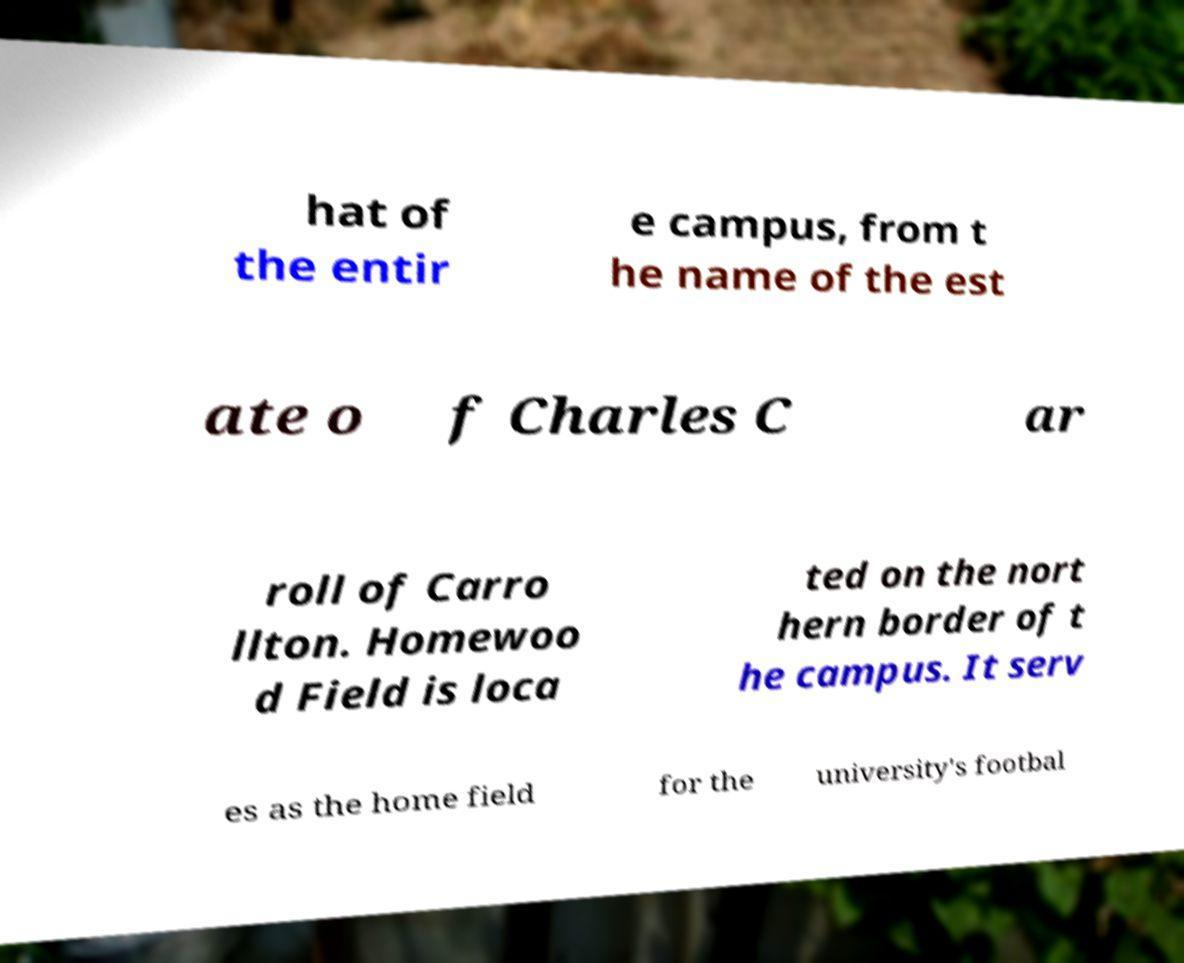Could you extract and type out the text from this image? hat of the entir e campus, from t he name of the est ate o f Charles C ar roll of Carro llton. Homewoo d Field is loca ted on the nort hern border of t he campus. It serv es as the home field for the university's footbal 